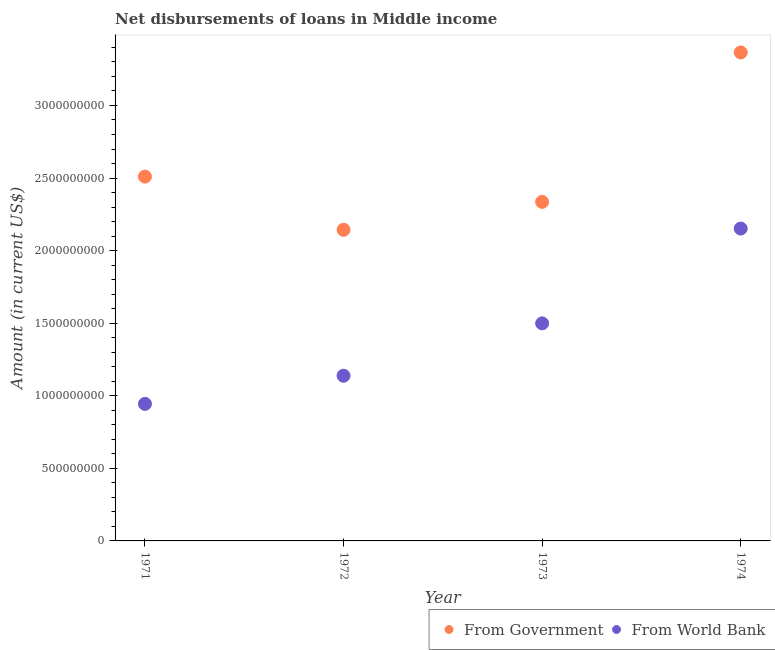How many different coloured dotlines are there?
Your response must be concise. 2. Is the number of dotlines equal to the number of legend labels?
Your response must be concise. Yes. What is the net disbursements of loan from government in 1974?
Provide a succinct answer. 3.37e+09. Across all years, what is the maximum net disbursements of loan from government?
Provide a succinct answer. 3.37e+09. Across all years, what is the minimum net disbursements of loan from government?
Keep it short and to the point. 2.14e+09. In which year was the net disbursements of loan from world bank maximum?
Provide a succinct answer. 1974. What is the total net disbursements of loan from world bank in the graph?
Provide a succinct answer. 5.73e+09. What is the difference between the net disbursements of loan from world bank in 1972 and that in 1973?
Provide a short and direct response. -3.61e+08. What is the difference between the net disbursements of loan from government in 1972 and the net disbursements of loan from world bank in 1973?
Offer a very short reply. 6.45e+08. What is the average net disbursements of loan from world bank per year?
Offer a terse response. 1.43e+09. In the year 1974, what is the difference between the net disbursements of loan from world bank and net disbursements of loan from government?
Ensure brevity in your answer.  -1.21e+09. What is the ratio of the net disbursements of loan from government in 1971 to that in 1972?
Give a very brief answer. 1.17. Is the net disbursements of loan from world bank in 1971 less than that in 1972?
Provide a short and direct response. Yes. Is the difference between the net disbursements of loan from government in 1972 and 1974 greater than the difference between the net disbursements of loan from world bank in 1972 and 1974?
Ensure brevity in your answer.  No. What is the difference between the highest and the second highest net disbursements of loan from world bank?
Your answer should be very brief. 6.53e+08. What is the difference between the highest and the lowest net disbursements of loan from world bank?
Your answer should be compact. 1.21e+09. In how many years, is the net disbursements of loan from government greater than the average net disbursements of loan from government taken over all years?
Your answer should be compact. 1. Is the sum of the net disbursements of loan from government in 1973 and 1974 greater than the maximum net disbursements of loan from world bank across all years?
Your answer should be very brief. Yes. Does the net disbursements of loan from world bank monotonically increase over the years?
Your response must be concise. Yes. Is the net disbursements of loan from government strictly greater than the net disbursements of loan from world bank over the years?
Your answer should be compact. Yes. Is the net disbursements of loan from world bank strictly less than the net disbursements of loan from government over the years?
Your answer should be compact. Yes. What is the difference between two consecutive major ticks on the Y-axis?
Ensure brevity in your answer.  5.00e+08. Does the graph contain any zero values?
Ensure brevity in your answer.  No. Does the graph contain grids?
Provide a short and direct response. No. Where does the legend appear in the graph?
Make the answer very short. Bottom right. How many legend labels are there?
Your answer should be very brief. 2. What is the title of the graph?
Provide a succinct answer. Net disbursements of loans in Middle income. Does "From production" appear as one of the legend labels in the graph?
Offer a very short reply. No. What is the Amount (in current US$) of From Government in 1971?
Ensure brevity in your answer.  2.51e+09. What is the Amount (in current US$) in From World Bank in 1971?
Keep it short and to the point. 9.44e+08. What is the Amount (in current US$) of From Government in 1972?
Your response must be concise. 2.14e+09. What is the Amount (in current US$) in From World Bank in 1972?
Give a very brief answer. 1.14e+09. What is the Amount (in current US$) of From Government in 1973?
Your answer should be compact. 2.34e+09. What is the Amount (in current US$) of From World Bank in 1973?
Offer a terse response. 1.50e+09. What is the Amount (in current US$) in From Government in 1974?
Offer a terse response. 3.37e+09. What is the Amount (in current US$) in From World Bank in 1974?
Offer a very short reply. 2.15e+09. Across all years, what is the maximum Amount (in current US$) of From Government?
Make the answer very short. 3.37e+09. Across all years, what is the maximum Amount (in current US$) of From World Bank?
Your response must be concise. 2.15e+09. Across all years, what is the minimum Amount (in current US$) of From Government?
Your response must be concise. 2.14e+09. Across all years, what is the minimum Amount (in current US$) of From World Bank?
Your answer should be very brief. 9.44e+08. What is the total Amount (in current US$) in From Government in the graph?
Your response must be concise. 1.04e+1. What is the total Amount (in current US$) of From World Bank in the graph?
Your answer should be compact. 5.73e+09. What is the difference between the Amount (in current US$) of From Government in 1971 and that in 1972?
Offer a very short reply. 3.67e+08. What is the difference between the Amount (in current US$) in From World Bank in 1971 and that in 1972?
Offer a terse response. -1.94e+08. What is the difference between the Amount (in current US$) in From Government in 1971 and that in 1973?
Give a very brief answer. 1.74e+08. What is the difference between the Amount (in current US$) in From World Bank in 1971 and that in 1973?
Provide a short and direct response. -5.55e+08. What is the difference between the Amount (in current US$) in From Government in 1971 and that in 1974?
Offer a terse response. -8.55e+08. What is the difference between the Amount (in current US$) in From World Bank in 1971 and that in 1974?
Your response must be concise. -1.21e+09. What is the difference between the Amount (in current US$) in From Government in 1972 and that in 1973?
Make the answer very short. -1.92e+08. What is the difference between the Amount (in current US$) of From World Bank in 1972 and that in 1973?
Offer a terse response. -3.61e+08. What is the difference between the Amount (in current US$) of From Government in 1972 and that in 1974?
Give a very brief answer. -1.22e+09. What is the difference between the Amount (in current US$) of From World Bank in 1972 and that in 1974?
Provide a short and direct response. -1.01e+09. What is the difference between the Amount (in current US$) in From Government in 1973 and that in 1974?
Make the answer very short. -1.03e+09. What is the difference between the Amount (in current US$) of From World Bank in 1973 and that in 1974?
Your response must be concise. -6.53e+08. What is the difference between the Amount (in current US$) of From Government in 1971 and the Amount (in current US$) of From World Bank in 1972?
Offer a terse response. 1.37e+09. What is the difference between the Amount (in current US$) in From Government in 1971 and the Amount (in current US$) in From World Bank in 1973?
Provide a succinct answer. 1.01e+09. What is the difference between the Amount (in current US$) in From Government in 1971 and the Amount (in current US$) in From World Bank in 1974?
Offer a very short reply. 3.58e+08. What is the difference between the Amount (in current US$) of From Government in 1972 and the Amount (in current US$) of From World Bank in 1973?
Offer a terse response. 6.45e+08. What is the difference between the Amount (in current US$) in From Government in 1972 and the Amount (in current US$) in From World Bank in 1974?
Keep it short and to the point. -8.54e+06. What is the difference between the Amount (in current US$) of From Government in 1973 and the Amount (in current US$) of From World Bank in 1974?
Ensure brevity in your answer.  1.84e+08. What is the average Amount (in current US$) of From Government per year?
Your response must be concise. 2.59e+09. What is the average Amount (in current US$) of From World Bank per year?
Give a very brief answer. 1.43e+09. In the year 1971, what is the difference between the Amount (in current US$) of From Government and Amount (in current US$) of From World Bank?
Keep it short and to the point. 1.57e+09. In the year 1972, what is the difference between the Amount (in current US$) in From Government and Amount (in current US$) in From World Bank?
Provide a short and direct response. 1.01e+09. In the year 1973, what is the difference between the Amount (in current US$) in From Government and Amount (in current US$) in From World Bank?
Keep it short and to the point. 8.37e+08. In the year 1974, what is the difference between the Amount (in current US$) in From Government and Amount (in current US$) in From World Bank?
Make the answer very short. 1.21e+09. What is the ratio of the Amount (in current US$) of From Government in 1971 to that in 1972?
Keep it short and to the point. 1.17. What is the ratio of the Amount (in current US$) of From World Bank in 1971 to that in 1972?
Provide a succinct answer. 0.83. What is the ratio of the Amount (in current US$) of From Government in 1971 to that in 1973?
Make the answer very short. 1.07. What is the ratio of the Amount (in current US$) in From World Bank in 1971 to that in 1973?
Offer a very short reply. 0.63. What is the ratio of the Amount (in current US$) of From Government in 1971 to that in 1974?
Offer a terse response. 0.75. What is the ratio of the Amount (in current US$) of From World Bank in 1971 to that in 1974?
Make the answer very short. 0.44. What is the ratio of the Amount (in current US$) of From Government in 1972 to that in 1973?
Offer a terse response. 0.92. What is the ratio of the Amount (in current US$) in From World Bank in 1972 to that in 1973?
Ensure brevity in your answer.  0.76. What is the ratio of the Amount (in current US$) of From Government in 1972 to that in 1974?
Offer a terse response. 0.64. What is the ratio of the Amount (in current US$) in From World Bank in 1972 to that in 1974?
Make the answer very short. 0.53. What is the ratio of the Amount (in current US$) in From Government in 1973 to that in 1974?
Offer a terse response. 0.69. What is the ratio of the Amount (in current US$) of From World Bank in 1973 to that in 1974?
Offer a very short reply. 0.7. What is the difference between the highest and the second highest Amount (in current US$) in From Government?
Give a very brief answer. 8.55e+08. What is the difference between the highest and the second highest Amount (in current US$) in From World Bank?
Make the answer very short. 6.53e+08. What is the difference between the highest and the lowest Amount (in current US$) in From Government?
Keep it short and to the point. 1.22e+09. What is the difference between the highest and the lowest Amount (in current US$) in From World Bank?
Keep it short and to the point. 1.21e+09. 